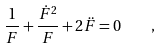<formula> <loc_0><loc_0><loc_500><loc_500>\frac { 1 } { F } + \frac { \dot { F } ^ { 2 } } { F } + 2 \ddot { F } = 0 \quad ,</formula> 